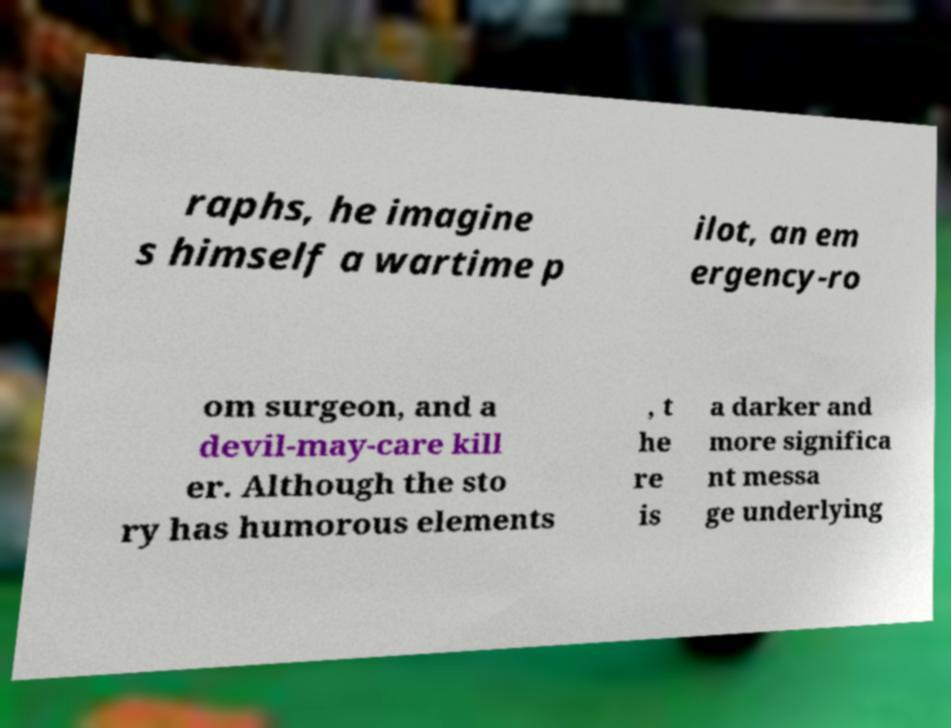Please identify and transcribe the text found in this image. raphs, he imagine s himself a wartime p ilot, an em ergency-ro om surgeon, and a devil-may-care kill er. Although the sto ry has humorous elements , t he re is a darker and more significa nt messa ge underlying 